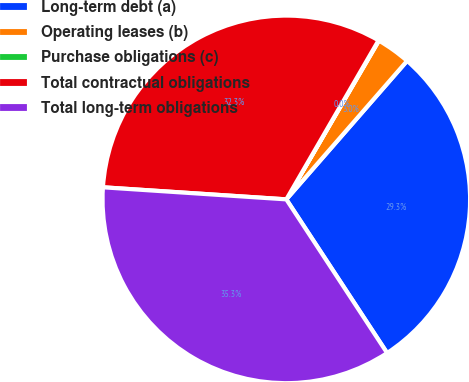<chart> <loc_0><loc_0><loc_500><loc_500><pie_chart><fcel>Long-term debt (a)<fcel>Operating leases (b)<fcel>Purchase obligations (c)<fcel>Total contractual obligations<fcel>Total long-term obligations<nl><fcel>29.35%<fcel>3.01%<fcel>0.04%<fcel>32.32%<fcel>35.29%<nl></chart> 